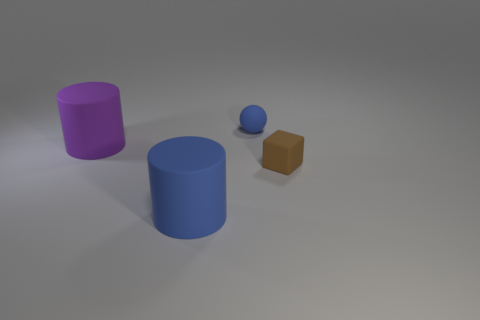Add 3 tiny rubber things. How many objects exist? 7 Subtract all purple cylinders. How many cylinders are left? 1 Subtract 1 cubes. How many cubes are left? 0 Subtract all gray balls. How many red blocks are left? 0 Subtract all purple metallic objects. Subtract all tiny balls. How many objects are left? 3 Add 1 big blue matte cylinders. How many big blue matte cylinders are left? 2 Add 3 brown cubes. How many brown cubes exist? 4 Subtract 1 purple cylinders. How many objects are left? 3 Subtract all blocks. How many objects are left? 3 Subtract all green cubes. Subtract all purple balls. How many cubes are left? 1 